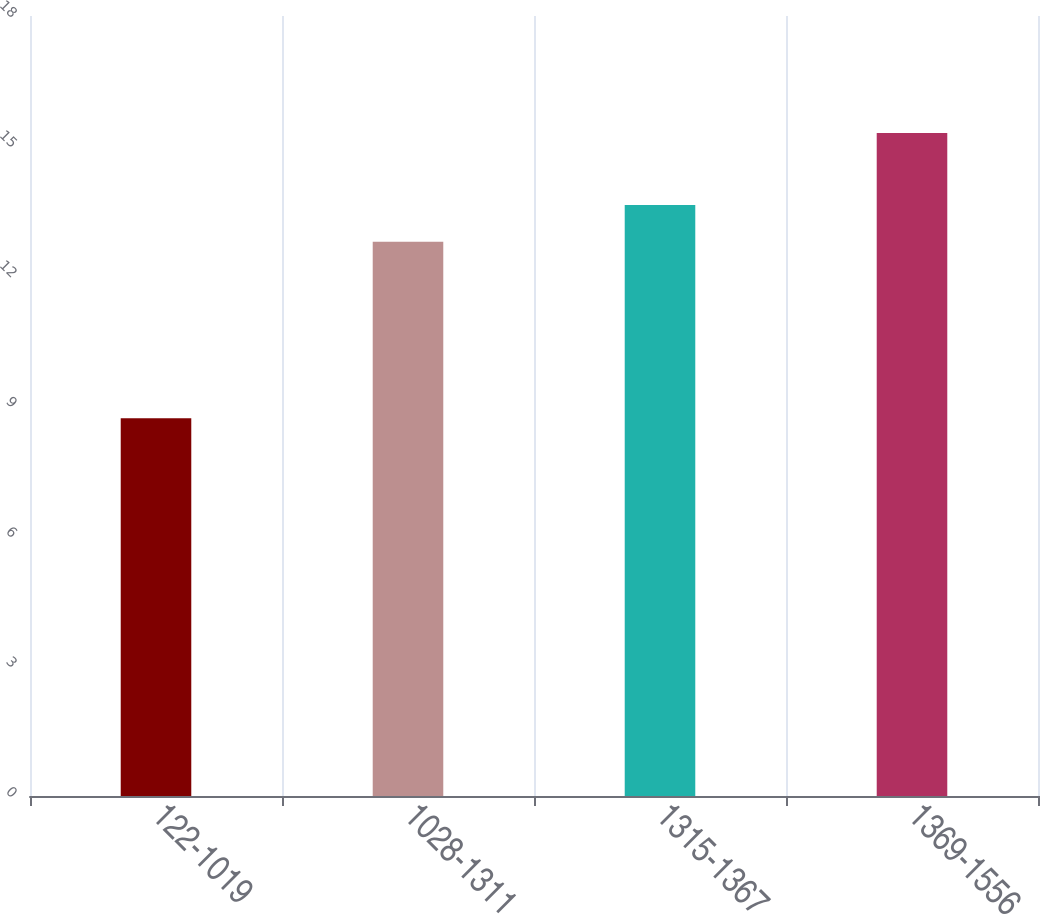Convert chart. <chart><loc_0><loc_0><loc_500><loc_500><bar_chart><fcel>122-1019<fcel>1028-1311<fcel>1315-1367<fcel>1369-1556<nl><fcel>8.72<fcel>12.79<fcel>13.64<fcel>15.3<nl></chart> 